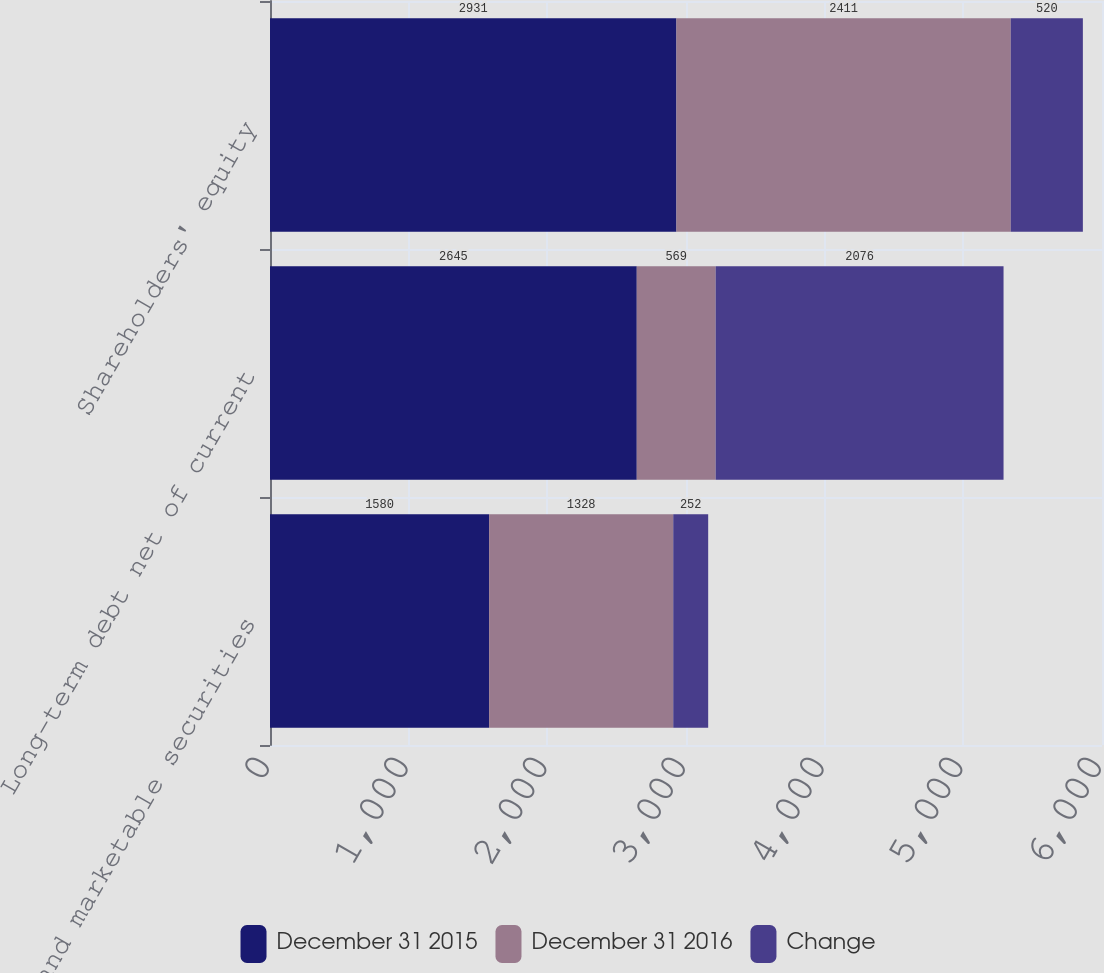<chart> <loc_0><loc_0><loc_500><loc_500><stacked_bar_chart><ecel><fcel>Cash and marketable securities<fcel>Long-term debt net of current<fcel>Shareholders' equity<nl><fcel>December 31 2015<fcel>1580<fcel>2645<fcel>2931<nl><fcel>December 31 2016<fcel>1328<fcel>569<fcel>2411<nl><fcel>Change<fcel>252<fcel>2076<fcel>520<nl></chart> 